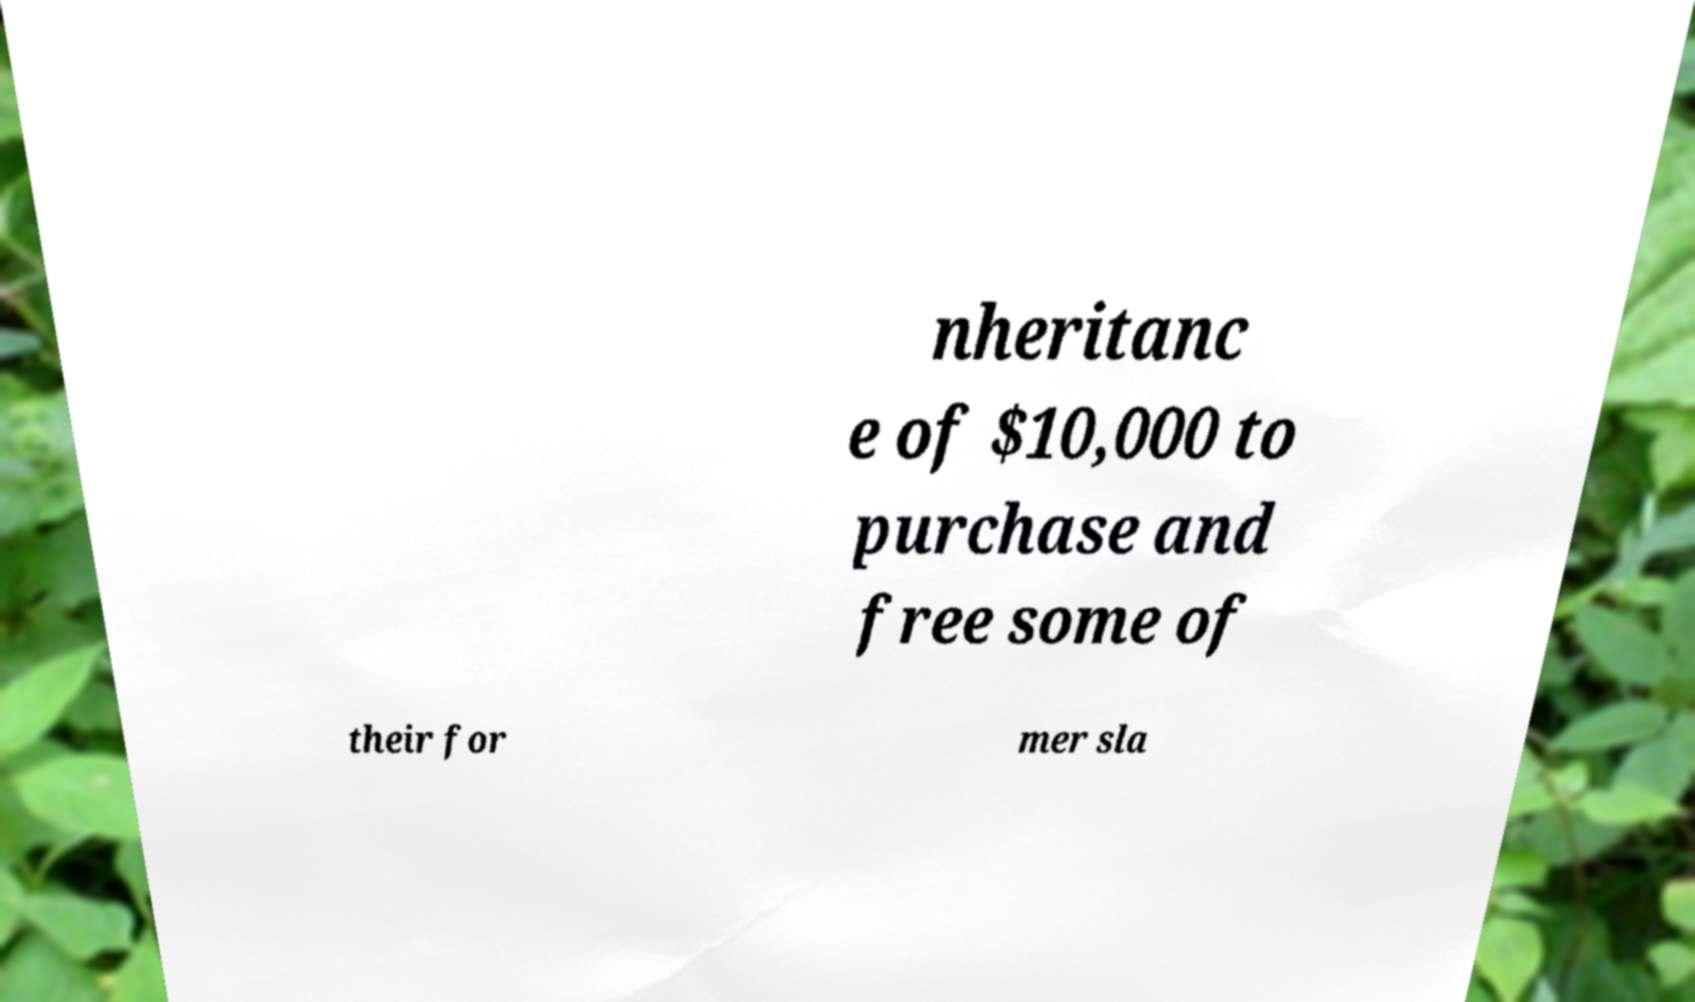I need the written content from this picture converted into text. Can you do that? nheritanc e of $10,000 to purchase and free some of their for mer sla 